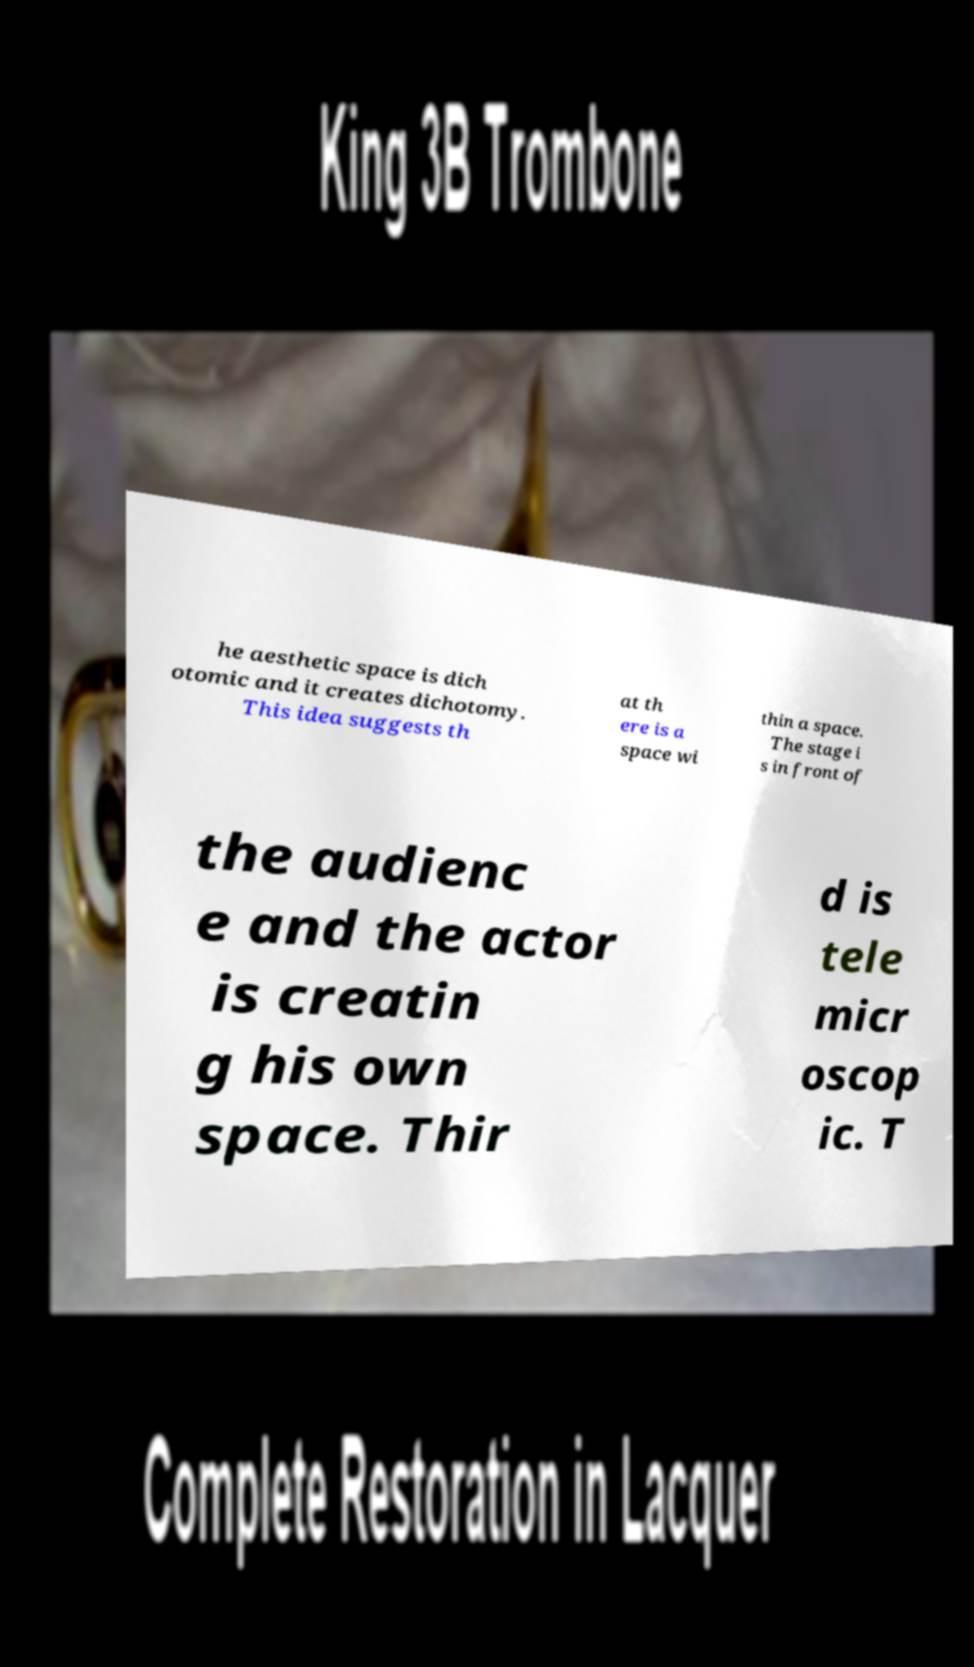Can you accurately transcribe the text from the provided image for me? he aesthetic space is dich otomic and it creates dichotomy. This idea suggests th at th ere is a space wi thin a space. The stage i s in front of the audienc e and the actor is creatin g his own space. Thir d is tele micr oscop ic. T 